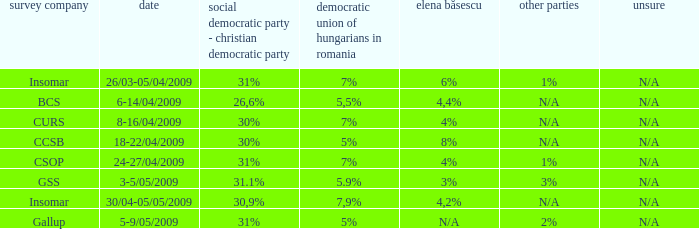What is the elena basescu when the poling firm of gallup? N/A. 